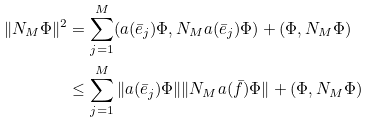<formula> <loc_0><loc_0><loc_500><loc_500>\| N _ { M } \Phi \| ^ { 2 } & = \sum _ { j = 1 } ^ { M } ( a ( \bar { e } _ { j } ) \Phi , N _ { M } a ( \bar { e } _ { j } ) \Phi ) + ( \Phi , N _ { M } \Phi ) \\ & \leq \sum _ { j = 1 } ^ { M } \| a ( \bar { e } _ { j } ) \Phi \| \| N _ { M } a ( \bar { f } ) \Phi \| + ( \Phi , N _ { M } \Phi )</formula> 